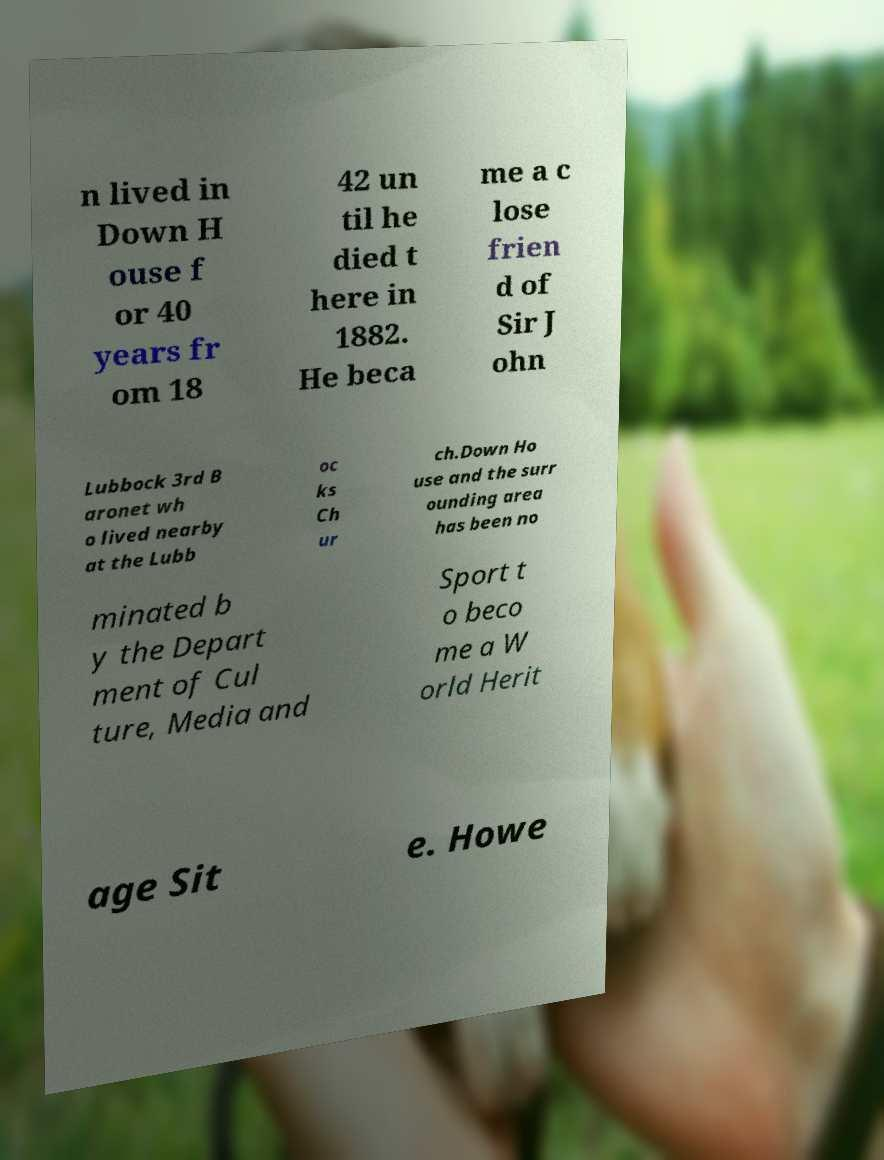Can you accurately transcribe the text from the provided image for me? n lived in Down H ouse f or 40 years fr om 18 42 un til he died t here in 1882. He beca me a c lose frien d of Sir J ohn Lubbock 3rd B aronet wh o lived nearby at the Lubb oc ks Ch ur ch.Down Ho use and the surr ounding area has been no minated b y the Depart ment of Cul ture, Media and Sport t o beco me a W orld Herit age Sit e. Howe 